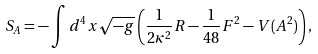<formula> <loc_0><loc_0><loc_500><loc_500>S _ { A } = - \int d ^ { 4 } x \sqrt { - g } \left ( \frac { 1 } { 2 \kappa ^ { 2 } } R - \frac { 1 } { 4 8 } F ^ { 2 } - V ( A ^ { 2 } ) \right ) ,</formula> 